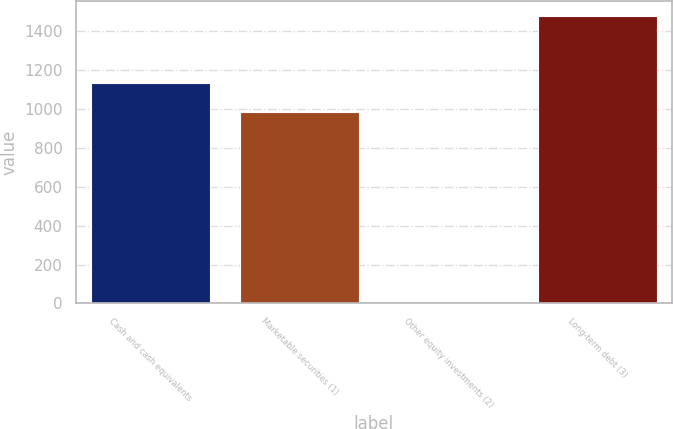<chart> <loc_0><loc_0><loc_500><loc_500><bar_chart><fcel>Cash and cash equivalents<fcel>Marketable securities (1)<fcel>Other equity investments (2)<fcel>Long-term debt (3)<nl><fcel>1134.2<fcel>987<fcel>8<fcel>1480<nl></chart> 